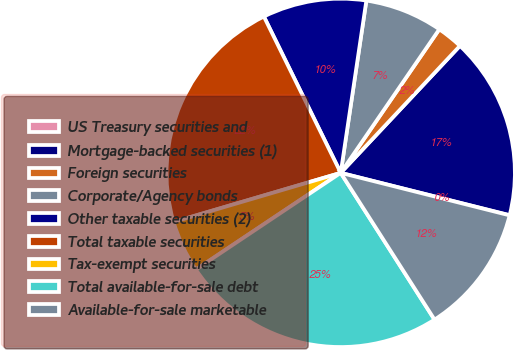<chart> <loc_0><loc_0><loc_500><loc_500><pie_chart><fcel>US Treasury securities and<fcel>Mortgage-backed securities (1)<fcel>Foreign securities<fcel>Corporate/Agency bonds<fcel>Other taxable securities (2)<fcel>Total taxable securities<fcel>Tax-exempt securities<fcel>Total available-for-sale debt<fcel>Available-for-sale marketable<nl><fcel>0.02%<fcel>16.9%<fcel>2.42%<fcel>7.22%<fcel>9.62%<fcel>22.27%<fcel>4.82%<fcel>24.67%<fcel>12.02%<nl></chart> 